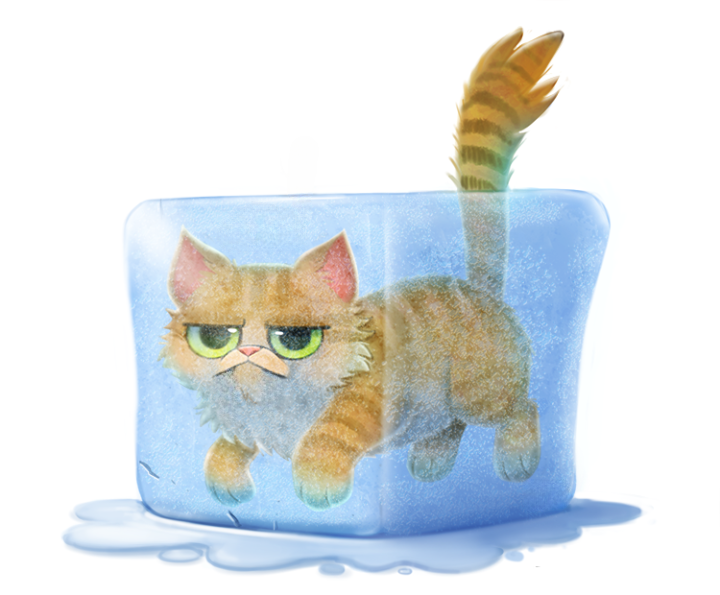Please describe this image as accurately as possible, and make sure to go over every possible detail as well. The image depicts a digital illustration of a cute, grumpy-looking cat emerging from what appears to be a melting block of ice or a puddle of water. The cat has orange and brown tabby fur with darker stripes. Its green eyes have an annoyed or irritated expression, with the brows furrowed above them. The cat's tail is raised up behind it, showing tufts of fur at the tip.

The cat seems to be partially submerged in the blue, semi-transparent liquid or ice block, with its head, front paws, and tail sticking out. The block has a slightly irregular, rounded rectangular shape and looks like it is slowly melting or dissolving, with drips forming at the bottom.

The overall style is cartoonish and whimsical, using simple shapes and colors to create an amusing, lighthearted scene. The background is a plain white, putting the full focus on the cat and its unusual, chilly predicament. The illustration cleverly anthropomorphizes the feline to give it a relatable, disgruntled demeanor that many cat owners would recognize. 